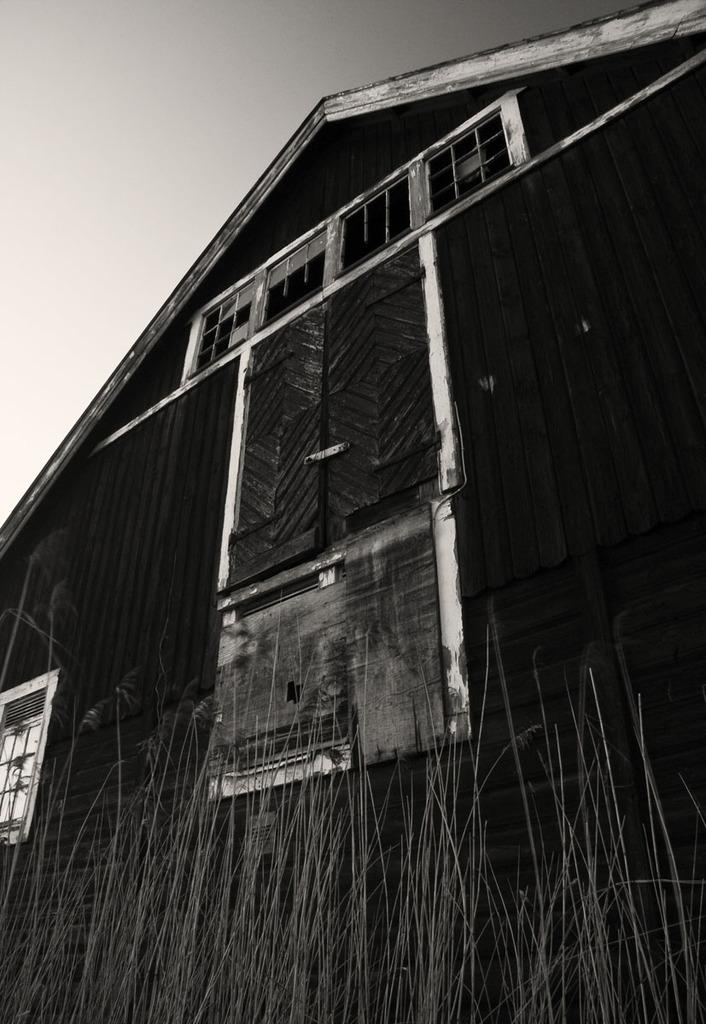What is the main structure in the image? There is a big building in the image. What type of vegetation is present in front of the building? There are grass plants in front of the building. What is the tendency of the volleyball players in the image? There are no volleyball players or any reference to volleyball in the image. 